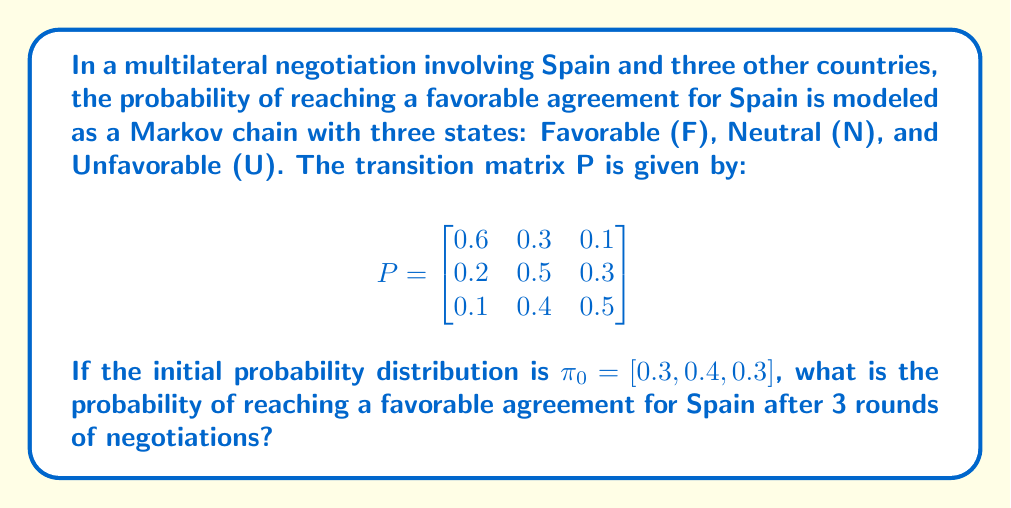Could you help me with this problem? To solve this problem, we need to follow these steps:

1) The initial probability distribution is given as $\pi_0 = [0.3, 0.4, 0.3]$.

2) We need to calculate $\pi_3 = \pi_0 P^3$, where $P^3$ is the transition matrix raised to the power of 3.

3) Let's calculate $P^2$ first:

   $$P^2 = P \cdot P = \begin{bmatrix}
   0.43 & 0.39 & 0.18 \\
   0.25 & 0.46 & 0.29 \\
   0.22 & 0.43 & 0.35
   \end{bmatrix}$$

4) Now, let's calculate $P^3$:

   $$P^3 = P^2 \cdot P = \begin{bmatrix}
   0.389 & 0.411 & 0.200 \\
   0.281 & 0.436 & 0.283 \\
   0.263 & 0.429 & 0.308
   \end{bmatrix}$$

5) Finally, we calculate $\pi_3$:

   $$\pi_3 = \pi_0 P^3 = [0.3, 0.4, 0.3] \cdot \begin{bmatrix}
   0.389 & 0.411 & 0.200 \\
   0.281 & 0.436 & 0.283 \\
   0.263 & 0.429 & 0.308
   \end{bmatrix}$$

   $$= [0.3(0.389) + 0.4(0.281) + 0.3(0.263), \, 0.3(0.411) + 0.4(0.436) + 0.3(0.429), \, 0.3(0.200) + 0.4(0.283) + 0.3(0.308)]$$

   $$= [0.311, 0.426, 0.263]$$

6) The probability of reaching a favorable agreement for Spain after 3 rounds is the first element of $\pi_3$, which is 0.311 or 31.1%.
Answer: 0.311 